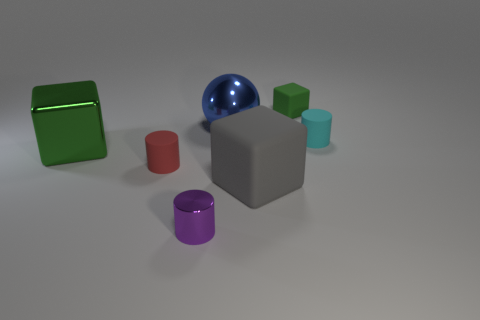There is a small red object that is made of the same material as the small green thing; what shape is it? cylinder 